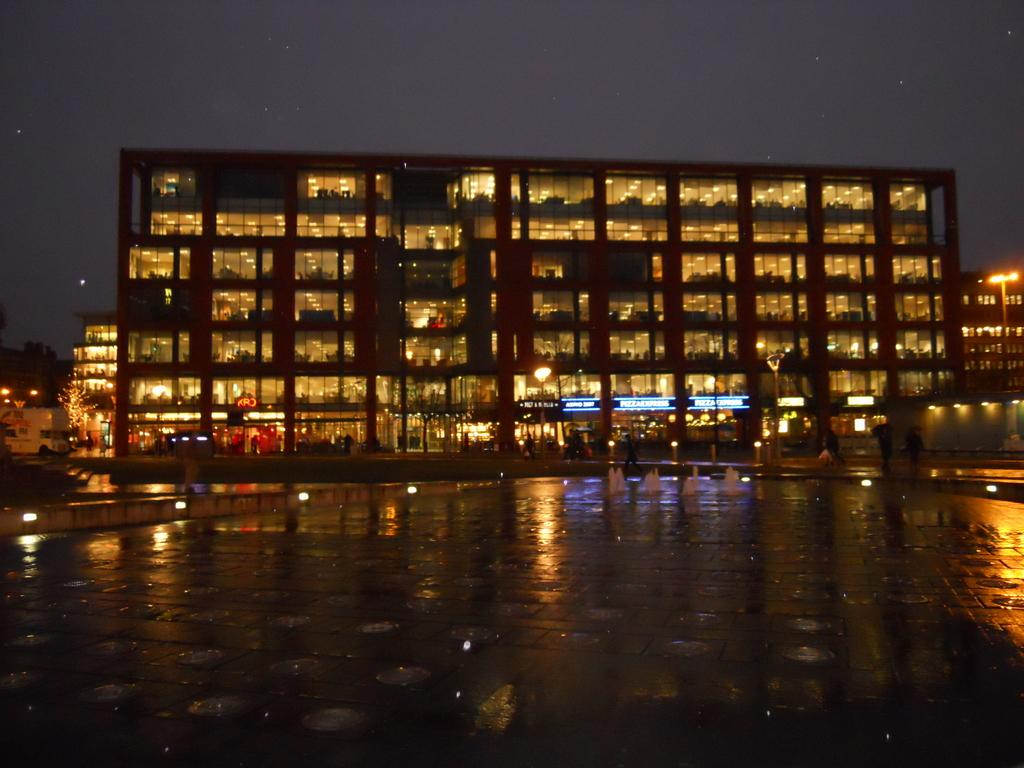What type of structures can be seen in the image? There are buildings in the image. What else is visible in the image besides the buildings? There are lights visible in the image, as well as the sky. What can be seen in the sky in the image? Stars are present in the sky in the image. What type of bait is used to attract the stars in the image? There is no bait present in the image, as the stars are celestial bodies and not attracted by any bait. 